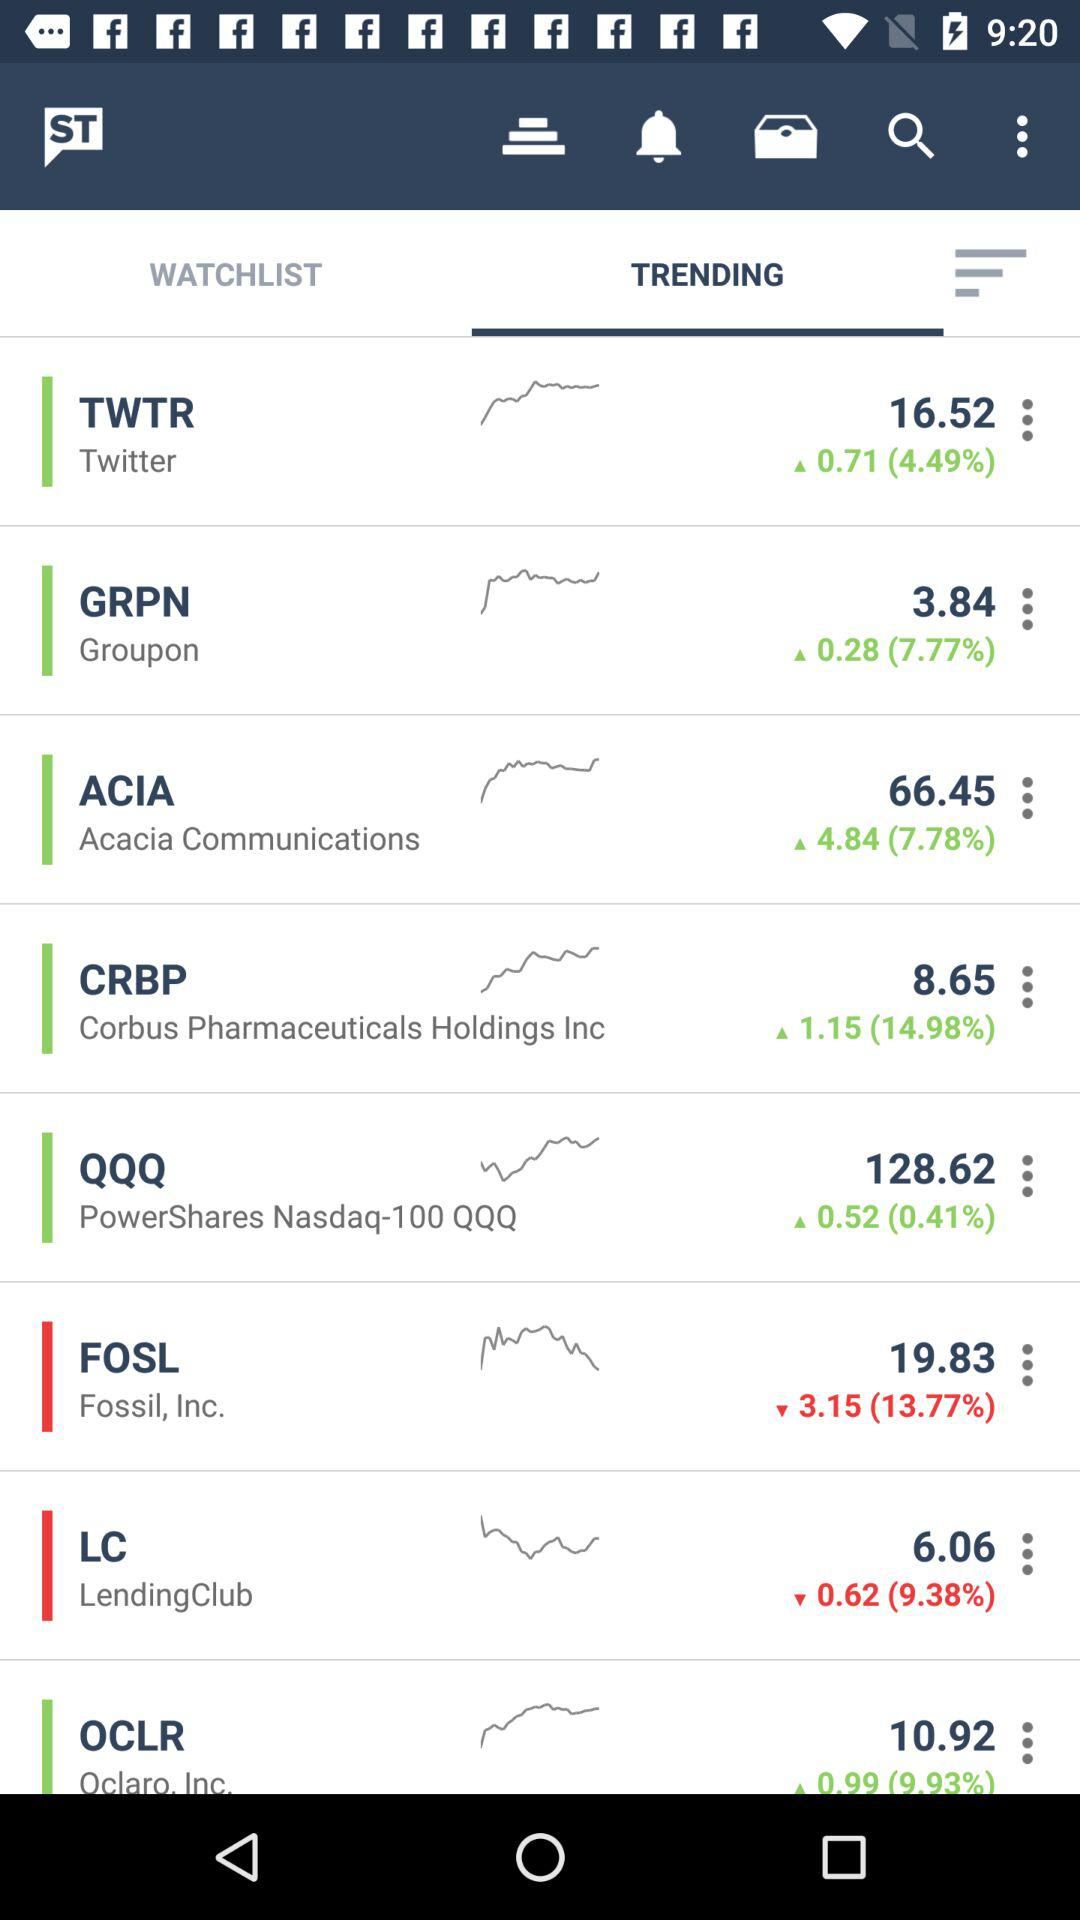What is the stock price of Twitter? The stock price is 16.52. 